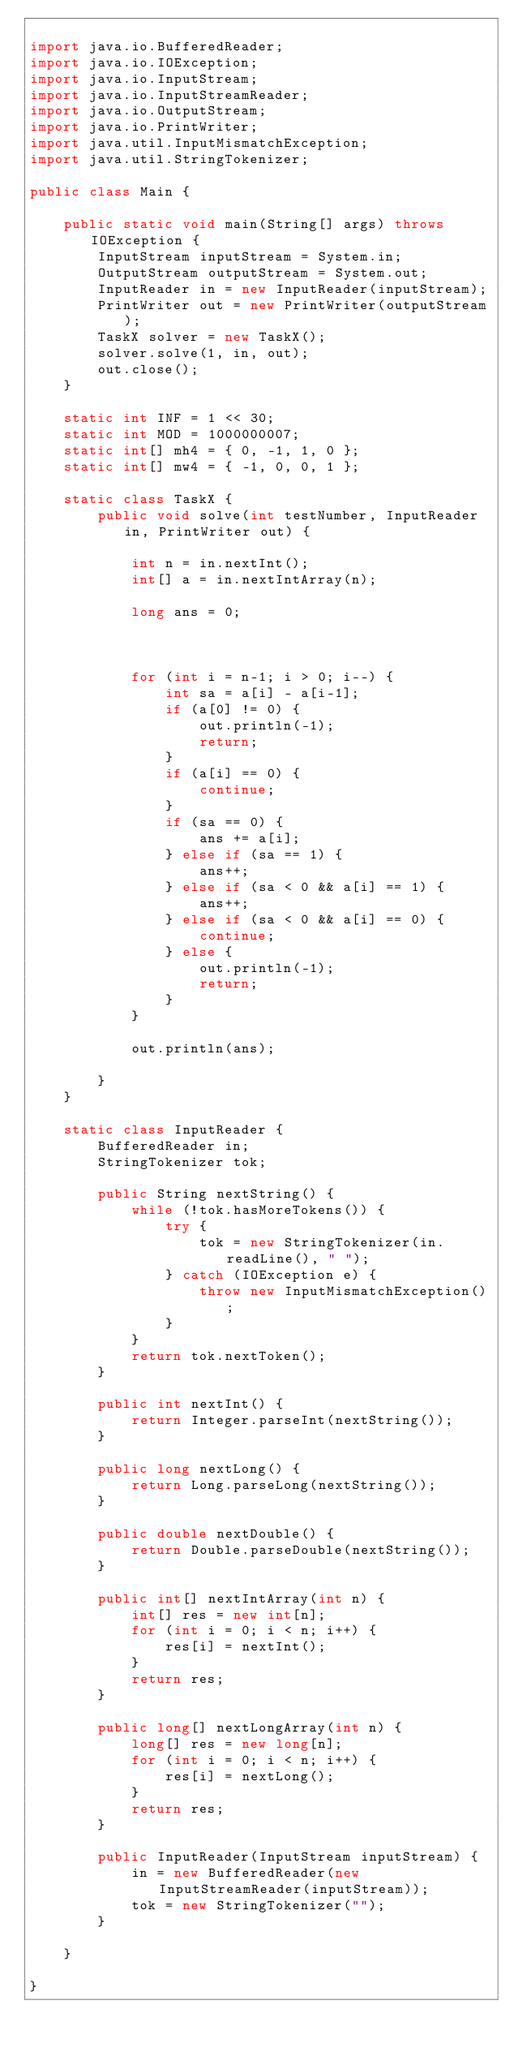<code> <loc_0><loc_0><loc_500><loc_500><_Java_>
import java.io.BufferedReader;
import java.io.IOException;
import java.io.InputStream;
import java.io.InputStreamReader;
import java.io.OutputStream;
import java.io.PrintWriter;
import java.util.InputMismatchException;
import java.util.StringTokenizer;

public class Main {

	public static void main(String[] args) throws IOException {
		InputStream inputStream = System.in;
		OutputStream outputStream = System.out;
		InputReader in = new InputReader(inputStream);
		PrintWriter out = new PrintWriter(outputStream);
		TaskX solver = new TaskX();
		solver.solve(1, in, out);
		out.close();
	}

	static int INF = 1 << 30;
	static int MOD = 1000000007;
	static int[] mh4 = { 0, -1, 1, 0 };
	static int[] mw4 = { -1, 0, 0, 1 };

	static class TaskX {
		public void solve(int testNumber, InputReader in, PrintWriter out) {

			int n = in.nextInt();
			int[] a = in.nextIntArray(n);

			long ans = 0;



			for (int i = n-1; i > 0; i--) {
				int sa = a[i] - a[i-1];
				if (a[0] != 0) {
					out.println(-1);
					return;
				}
				if (a[i] == 0) {
					continue;
				}
				if (sa == 0) {
					ans += a[i];
				} else if (sa == 1) {
					ans++;
				} else if (sa < 0 && a[i] == 1) {
					ans++;
				} else if (sa < 0 && a[i] == 0) {
					continue;
				} else {
					out.println(-1);
					return;
				}
			}

			out.println(ans);

		}
	}

	static class InputReader {
		BufferedReader in;
		StringTokenizer tok;

		public String nextString() {
			while (!tok.hasMoreTokens()) {
				try {
					tok = new StringTokenizer(in.readLine(), " ");
				} catch (IOException e) {
					throw new InputMismatchException();
				}
			}
			return tok.nextToken();
		}

		public int nextInt() {
			return Integer.parseInt(nextString());
		}

		public long nextLong() {
			return Long.parseLong(nextString());
		}

		public double nextDouble() {
			return Double.parseDouble(nextString());
		}

		public int[] nextIntArray(int n) {
			int[] res = new int[n];
			for (int i = 0; i < n; i++) {
				res[i] = nextInt();
			}
			return res;
		}

		public long[] nextLongArray(int n) {
			long[] res = new long[n];
			for (int i = 0; i < n; i++) {
				res[i] = nextLong();
			}
			return res;
		}

		public InputReader(InputStream inputStream) {
			in = new BufferedReader(new InputStreamReader(inputStream));
			tok = new StringTokenizer("");
		}

	}

}
</code> 